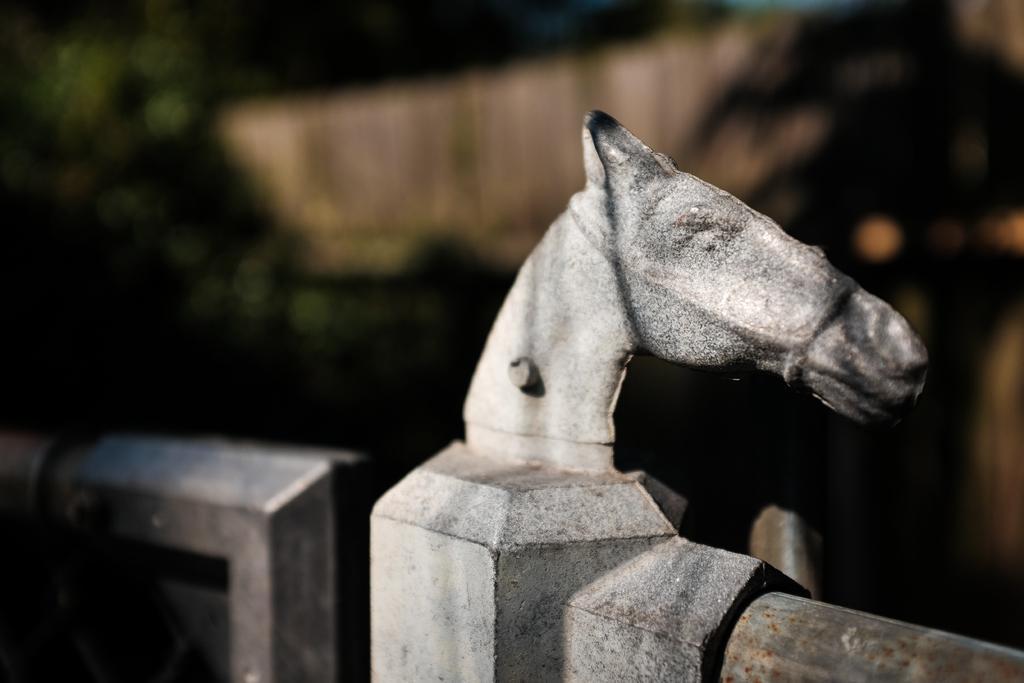Can you describe this image briefly? In this image there is a sculpture on the wall. The sculpture is the head of a horse. The background is blurry. 